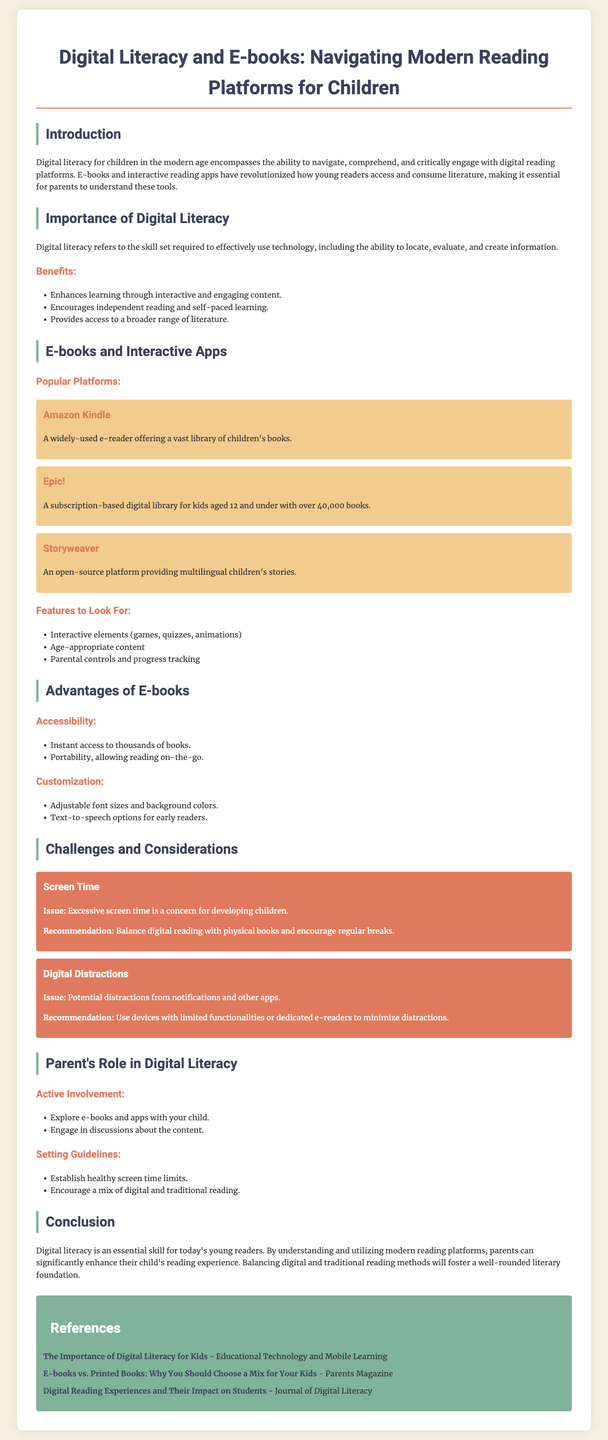What is the title of the document? The title is presented prominently at the top of the document, identifying the main subject.
Answer: Digital Literacy and E-books: Navigating Modern Reading Platforms for Children What is the age range for the Epic! digital library? The document specifies the target audience for Epic! as kids aged 12 and under.
Answer: 12 and under What are two benefits of digital literacy mentioned in the document? The benefits are outlined in a list, highlighting the positive aspects of digital literacy for children.
Answer: Enhances learning, encourages independent reading What is one challenge related to screen time mentioned? The challenge is highlighted in a specific section of the document detailing concerns regarding excessive screen exposure.
Answer: Excessive screen time Name one of the features to look for in e-books and interactive apps. Features are described in a bulleted list, offering parents guidance on selecting good platforms.
Answer: Interactive elements What role should parents take in their child's digital literacy? The document outlines responsibilities for parents, suggesting active involvement and engagement with their child's reading.
Answer: Active involvement How many books does the Epic! platform offer? This detail is provided to inform readers about the extensive library available on the platform.
Answer: Over 40,000 books What is recommended for balancing digital reading? The recommendation focuses on maintaining a healthy mix in children's reading habits as mentioned in the document.
Answer: Balance digital reading with physical books 